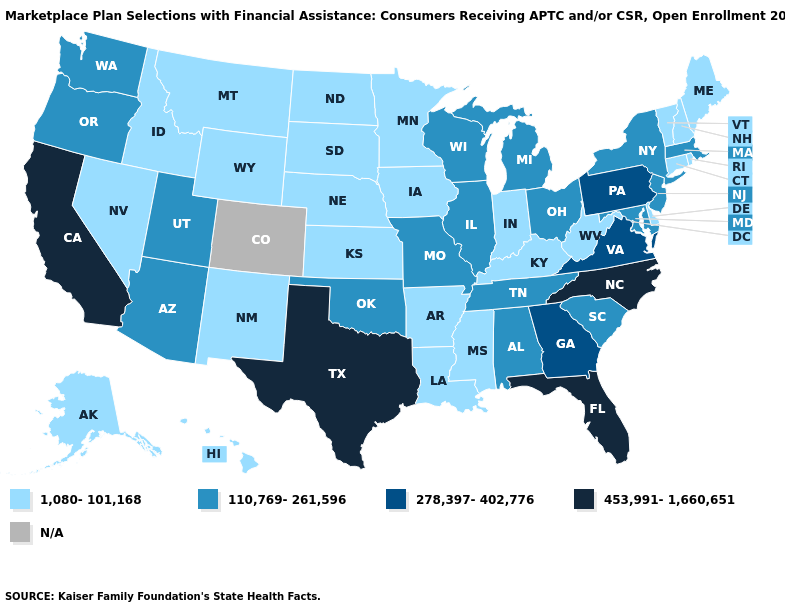Name the states that have a value in the range 278,397-402,776?
Be succinct. Georgia, Pennsylvania, Virginia. Does New Jersey have the highest value in the Northeast?
Concise answer only. No. Among the states that border Oregon , does Washington have the highest value?
Keep it brief. No. What is the highest value in the MidWest ?
Concise answer only. 110,769-261,596. What is the highest value in the Northeast ?
Be succinct. 278,397-402,776. What is the highest value in the USA?
Write a very short answer. 453,991-1,660,651. What is the highest value in states that border Utah?
Quick response, please. 110,769-261,596. What is the value of Missouri?
Give a very brief answer. 110,769-261,596. What is the value of Ohio?
Quick response, please. 110,769-261,596. What is the highest value in the MidWest ?
Keep it brief. 110,769-261,596. Does the map have missing data?
Keep it brief. Yes. Among the states that border Kansas , which have the lowest value?
Be succinct. Nebraska. What is the value of Wisconsin?
Answer briefly. 110,769-261,596. 